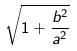Convert formula to latex. <formula><loc_0><loc_0><loc_500><loc_500>\sqrt { 1 + \frac { b ^ { 2 } } { a ^ { 2 } } }</formula> 